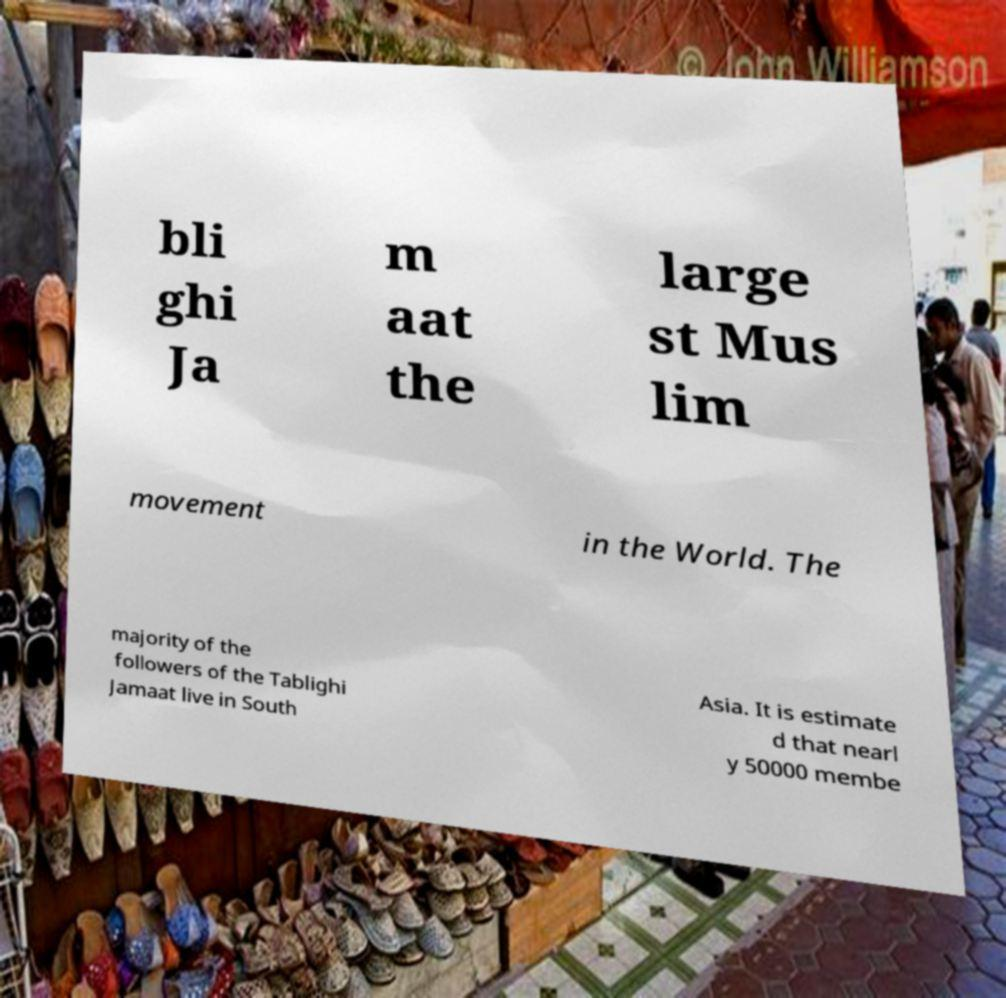Please read and relay the text visible in this image. What does it say? bli ghi Ja m aat the large st Mus lim movement in the World. The majority of the followers of the Tablighi Jamaat live in South Asia. It is estimate d that nearl y 50000 membe 